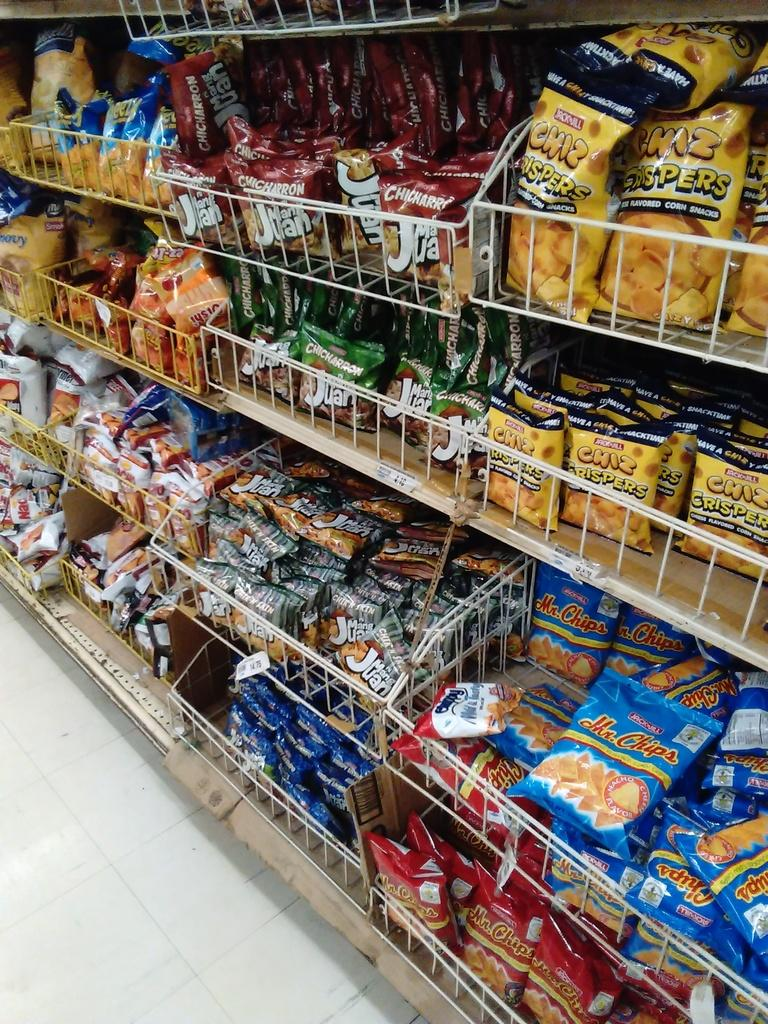<image>
Provide a brief description of the given image. the word crispers is on one of the bags 